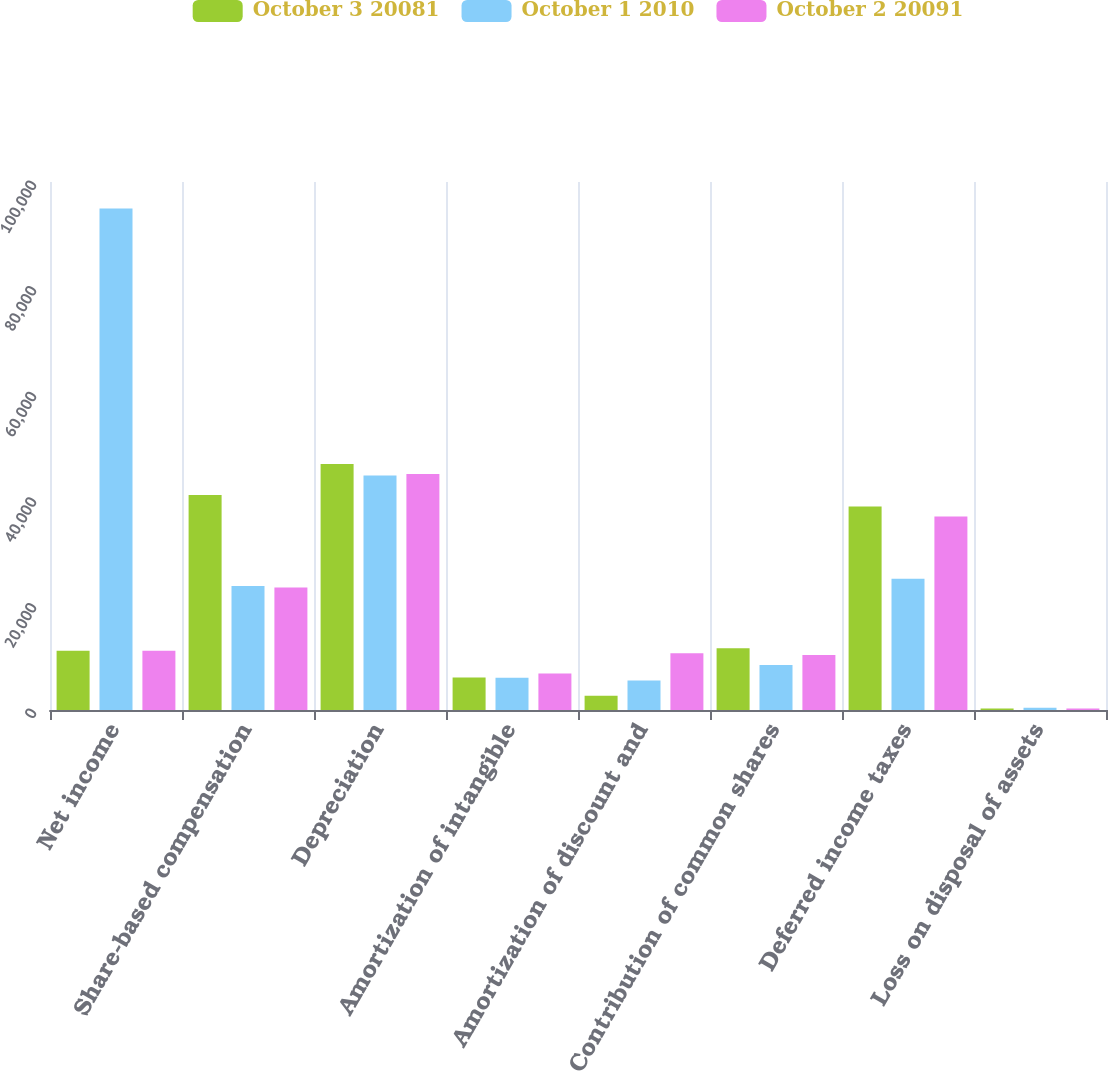<chart> <loc_0><loc_0><loc_500><loc_500><stacked_bar_chart><ecel><fcel>Net income<fcel>Share-based compensation<fcel>Depreciation<fcel>Amortization of intangible<fcel>Amortization of discount and<fcel>Contribution of common shares<fcel>Deferred income taxes<fcel>Loss on disposal of assets<nl><fcel>October 3 20081<fcel>11227<fcel>40741<fcel>46573<fcel>6136<fcel>2693<fcel>11706<fcel>38543<fcel>292<nl><fcel>October 1 2010<fcel>94983<fcel>23466<fcel>44413<fcel>6118<fcel>5589<fcel>8502<fcel>24866<fcel>411<nl><fcel>October 2 20091<fcel>11227<fcel>23212<fcel>44712<fcel>6933<fcel>10748<fcel>10407<fcel>36648<fcel>276<nl></chart> 